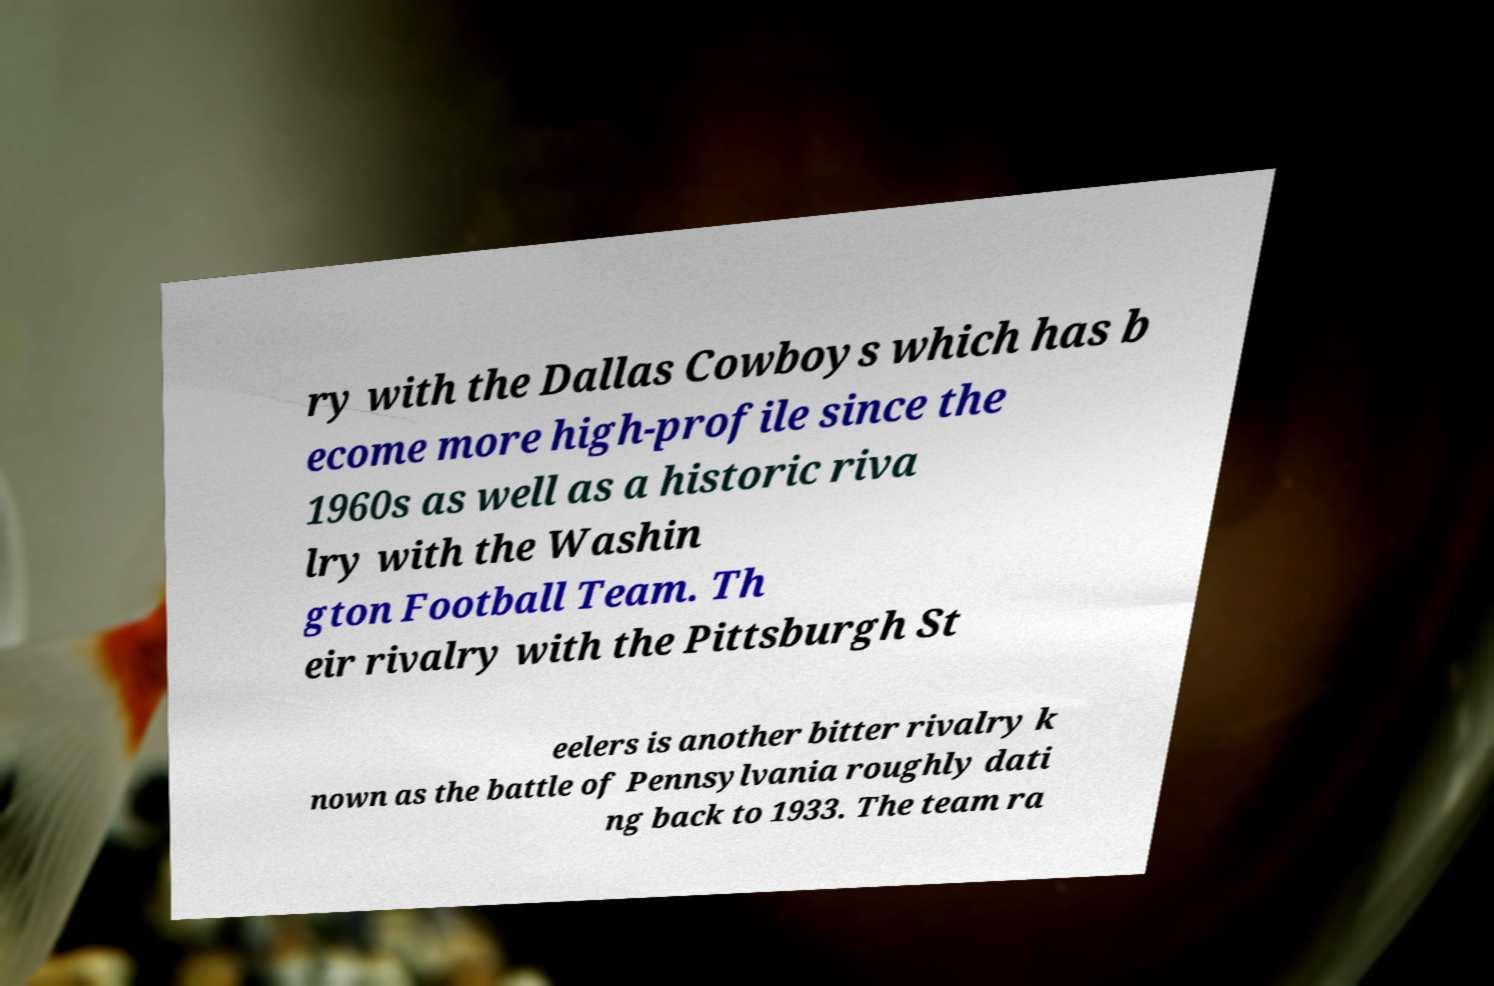Please read and relay the text visible in this image. What does it say? ry with the Dallas Cowboys which has b ecome more high-profile since the 1960s as well as a historic riva lry with the Washin gton Football Team. Th eir rivalry with the Pittsburgh St eelers is another bitter rivalry k nown as the battle of Pennsylvania roughly dati ng back to 1933. The team ra 